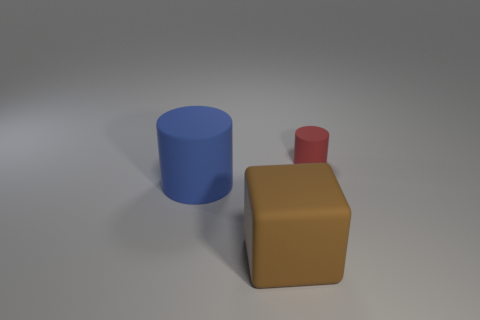Add 1 big brown things. How many objects exist? 4 Subtract all cubes. How many objects are left? 2 Subtract all blue cylinders. Subtract all green matte cubes. How many objects are left? 2 Add 3 big cylinders. How many big cylinders are left? 4 Add 2 small gray shiny cylinders. How many small gray shiny cylinders exist? 2 Subtract 0 purple balls. How many objects are left? 3 